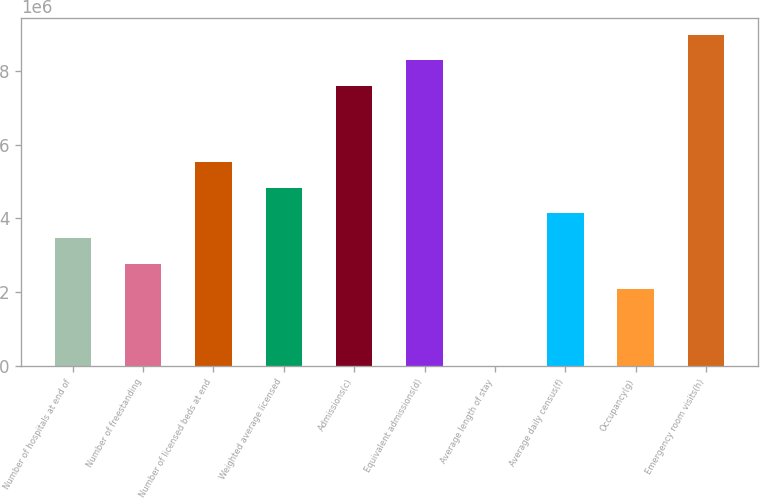<chart> <loc_0><loc_0><loc_500><loc_500><bar_chart><fcel>Number of hospitals at end of<fcel>Number of freestanding<fcel>Number of licensed beds at end<fcel>Weighted average licensed<fcel>Admissions(c)<fcel>Equivalent admissions(d)<fcel>Average length of stay<fcel>Average daily census(f)<fcel>Occupancy(g)<fcel>Emergency room visits(h)<nl><fcel>3.456e+06<fcel>2.7648e+06<fcel>5.5296e+06<fcel>4.8384e+06<fcel>7.6032e+06<fcel>8.2944e+06<fcel>4.7<fcel>4.1472e+06<fcel>2.0736e+06<fcel>8.9856e+06<nl></chart> 